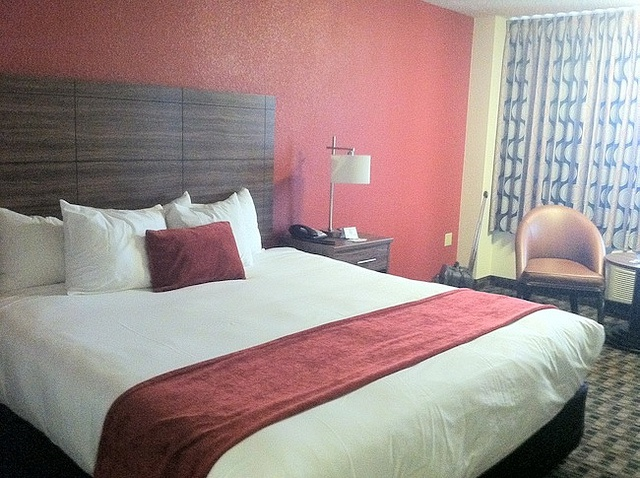Describe the objects in this image and their specific colors. I can see bed in brown, lightgray, darkgray, gray, and black tones, chair in brown, darkgray, tan, gray, and lightgray tones, and suitcase in brown, gray, darkgray, and lightgray tones in this image. 